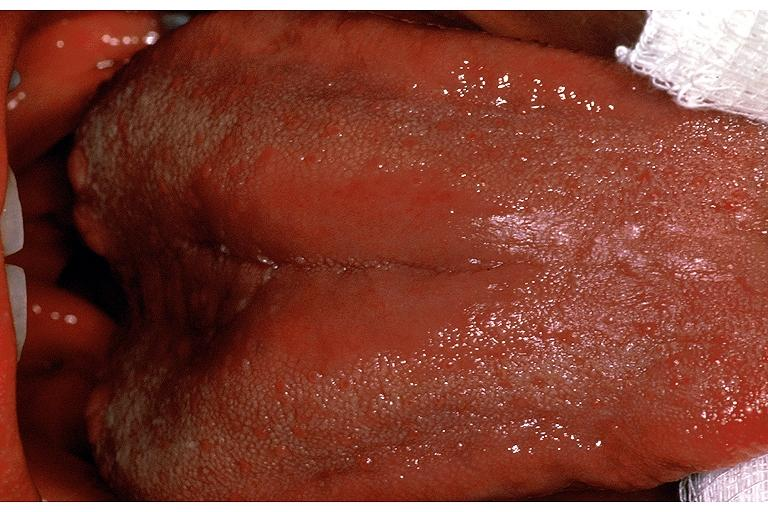does right leaf of diaphragm show median rhomboid glossitis?
Answer the question using a single word or phrase. No 